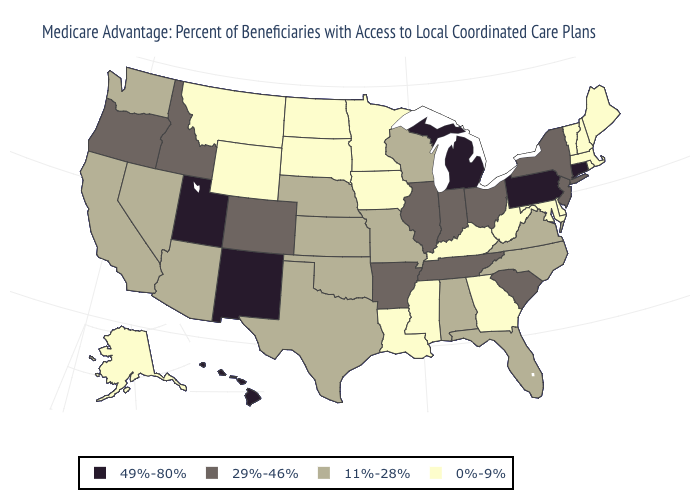Does Wyoming have the lowest value in the West?
Keep it brief. Yes. Name the states that have a value in the range 49%-80%?
Give a very brief answer. Connecticut, Hawaii, Michigan, New Mexico, Pennsylvania, Utah. Name the states that have a value in the range 49%-80%?
Quick response, please. Connecticut, Hawaii, Michigan, New Mexico, Pennsylvania, Utah. Does South Dakota have the lowest value in the USA?
Quick response, please. Yes. Name the states that have a value in the range 0%-9%?
Be succinct. Alaska, Delaware, Georgia, Iowa, Kentucky, Louisiana, Massachusetts, Maryland, Maine, Minnesota, Mississippi, Montana, North Dakota, New Hampshire, Rhode Island, South Dakota, Vermont, West Virginia, Wyoming. Name the states that have a value in the range 29%-46%?
Keep it brief. Arkansas, Colorado, Idaho, Illinois, Indiana, New Jersey, New York, Ohio, Oregon, South Carolina, Tennessee. Does South Carolina have the highest value in the South?
Short answer required. Yes. How many symbols are there in the legend?
Concise answer only. 4. What is the highest value in the USA?
Concise answer only. 49%-80%. Does Vermont have the lowest value in the Northeast?
Quick response, please. Yes. Which states hav the highest value in the Northeast?
Be succinct. Connecticut, Pennsylvania. Name the states that have a value in the range 0%-9%?
Concise answer only. Alaska, Delaware, Georgia, Iowa, Kentucky, Louisiana, Massachusetts, Maryland, Maine, Minnesota, Mississippi, Montana, North Dakota, New Hampshire, Rhode Island, South Dakota, Vermont, West Virginia, Wyoming. What is the lowest value in states that border South Carolina?
Quick response, please. 0%-9%. What is the lowest value in the USA?
Answer briefly. 0%-9%. Name the states that have a value in the range 11%-28%?
Be succinct. Alabama, Arizona, California, Florida, Kansas, Missouri, North Carolina, Nebraska, Nevada, Oklahoma, Texas, Virginia, Washington, Wisconsin. 